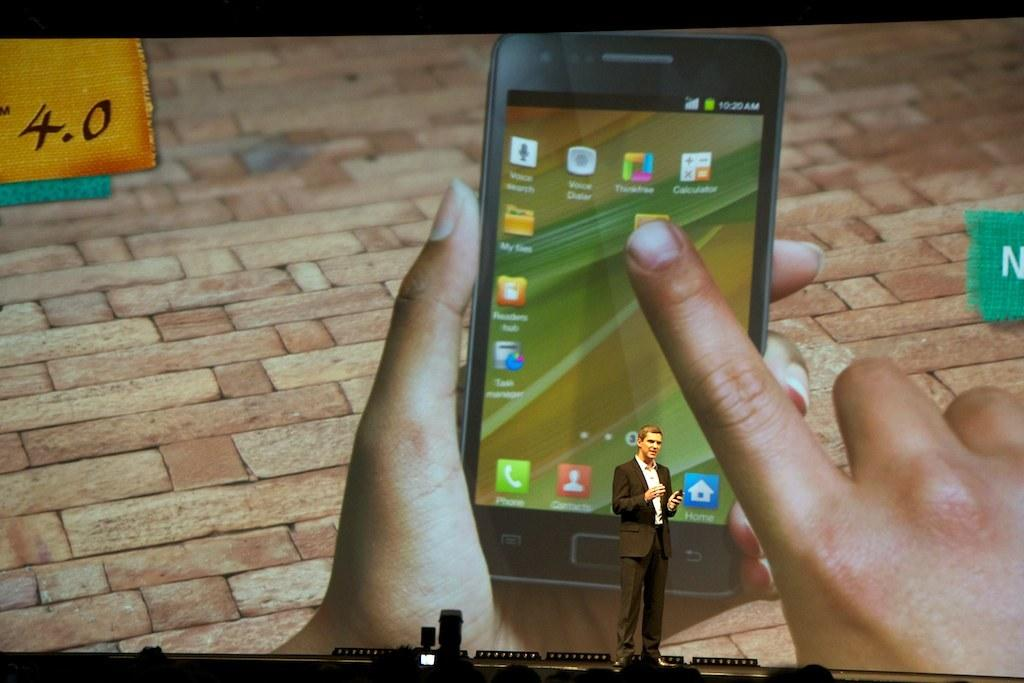<image>
Provide a brief description of the given image. a phone that has the word contacts on it 